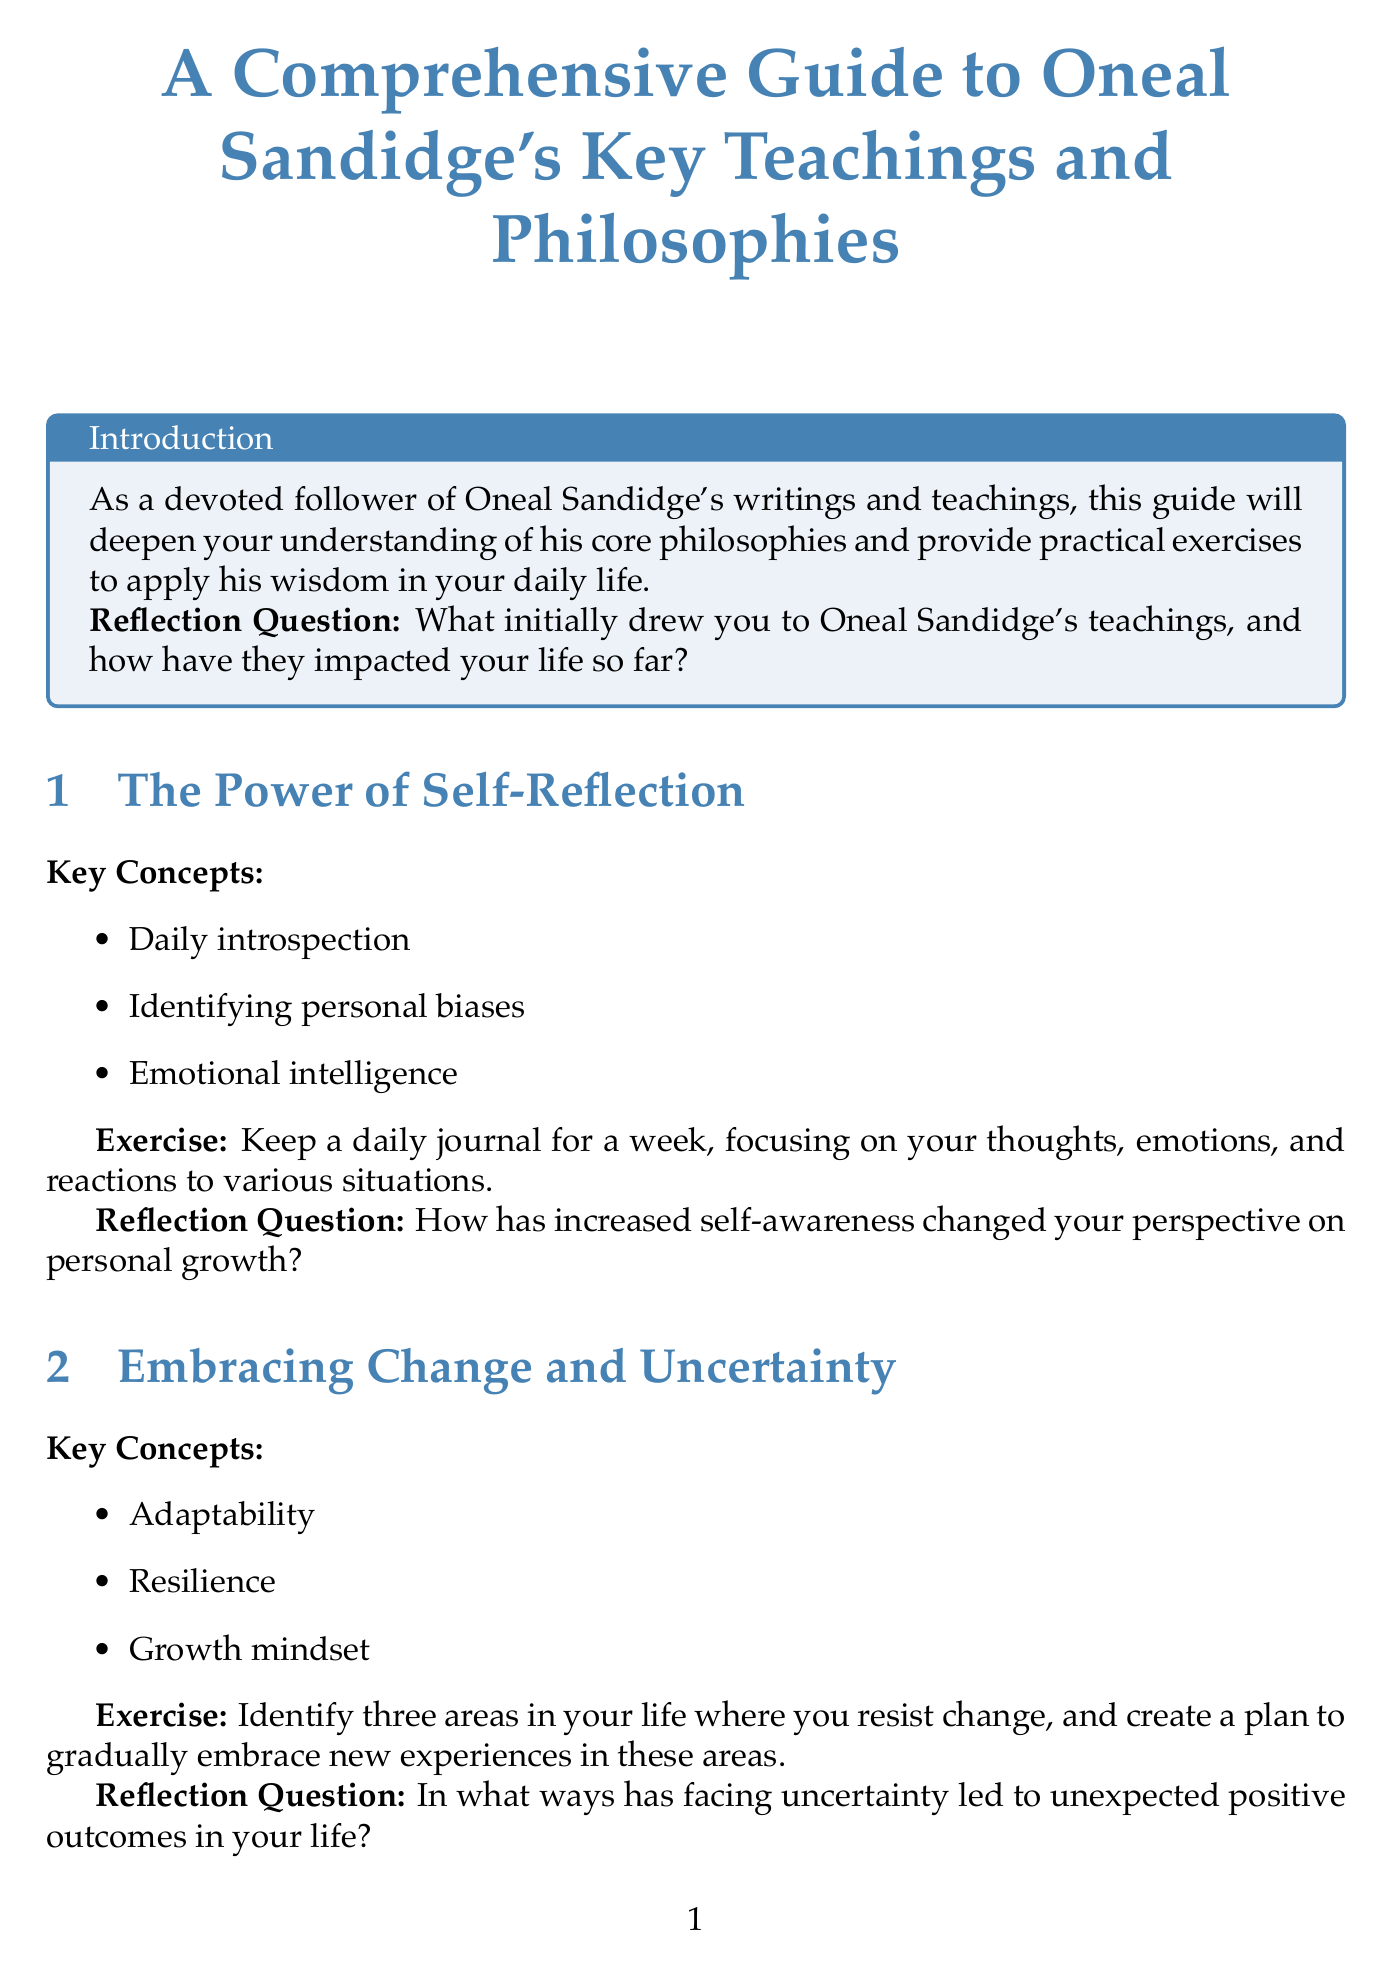What is the title of the guide? The title is presented in the document's header, listing the full name of the guide.
Answer: A Comprehensive Guide to Oneal Sandidge's Key Teachings and Philosophies What is the primary focus of the introduction? The introduction outlines the purpose of the guide, emphasizing its role in deepening understanding of Oneal Sandidge's teachings.
Answer: To deepen understanding of his core philosophies How many chapters are included in the guide? Counting the listed chapters provides insight into the structure of the document.
Answer: Five What is the first chapter about? The first chapter's title gives a clear indication of its content focus.
Answer: The Power of Self-Reflection What exercise is suggested in the chapter on gratitude? The exercise details are explicitly stated in the relevant section, revealing practical actions advised by the author.
Answer: Write a gratitude letter What is the key concept associated with "Embracing Change and Uncertainty"? The description in the chapter lists the main ideas related to this topic, indicating its central themes.
Answer: Resilience What reflection question is posed in the chapter on self-reflection? The document explicitly includes reflection questions in each chapter, aimed at prompting deeper thought.
Answer: How has increased self-awareness changed your perspective on personal growth? What is the final reflection question in the conclusion? The conclusion states a final reflection that encourages summarization of the reader's commitment to the teachings discussed throughout the guide.
Answer: How has this comprehensive exploration of Oneal Sandidge's teachings reinforced or evolved your commitment to his philosophies? Which book is recommended for further reading? The recommended readings section lists various titles for additional exploration of Oneal Sandidge's teachings.
Answer: The Path to Inner Peace by Oneal Sandidge 